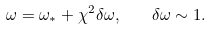<formula> <loc_0><loc_0><loc_500><loc_500>\omega = \omega _ { * } + \chi ^ { 2 } \delta \omega , \quad \delta \omega \sim 1 .</formula> 